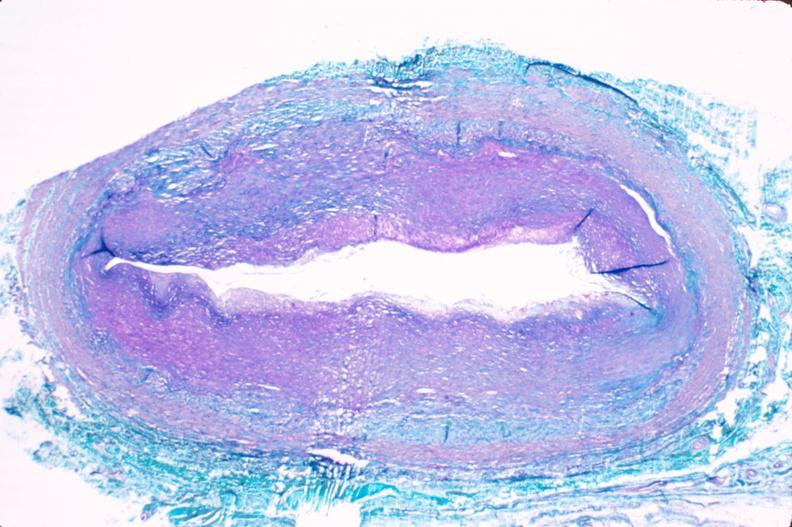what is present?
Answer the question using a single word or phrase. Vasculature 